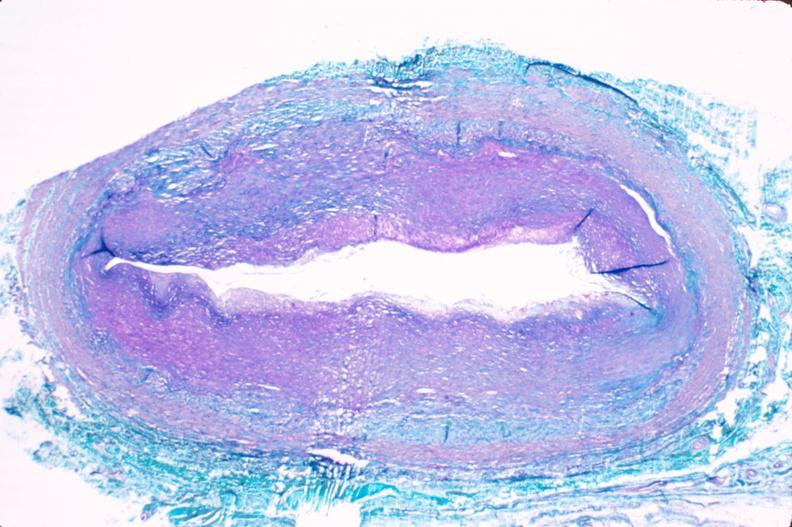what is present?
Answer the question using a single word or phrase. Vasculature 